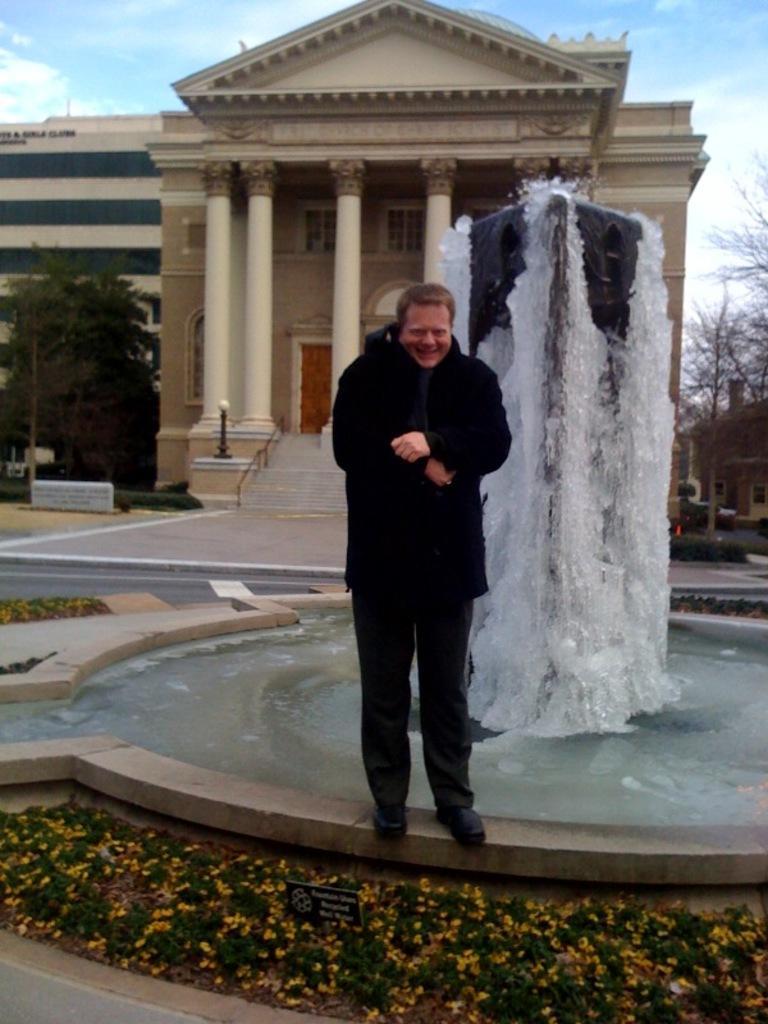Describe this image in one or two sentences. In the foreground of this image, at the bottom, there are flowers and plants. In the middle, there is a man standing in front of a fountain. In the background, there are buildings, trees, pavement, stairs, sky and the cloud 